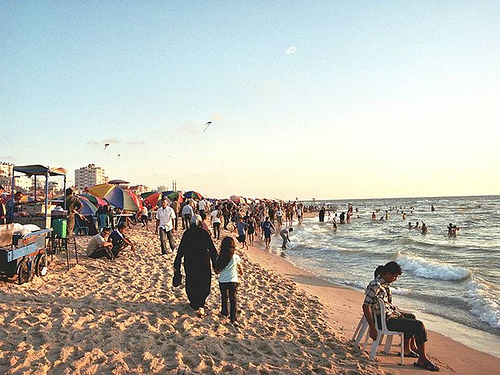What time of day does it appear to be in the image and how does this impact the scene? It appears to be late afternoon, as indicated by the long shadows and the soft golden hue of the sunlight. This timing enhances the scene by casting a warm glow over the beach, creating a relaxed and leisurely atmosphere that seems perfect for enjoying the end of a day by the sea. 